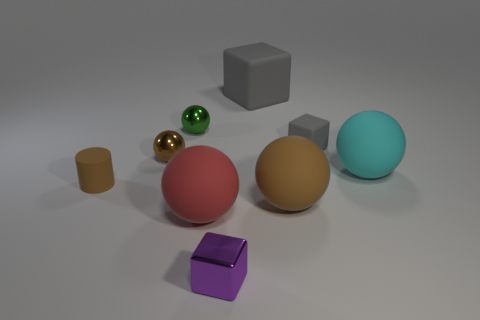Is there any other thing that has the same shape as the small brown rubber object?
Ensure brevity in your answer.  No. How big is the ball that is in front of the brown metal sphere and behind the brown cylinder?
Ensure brevity in your answer.  Large. There is a cube in front of the tiny matte object left of the big brown rubber thing; what color is it?
Keep it short and to the point. Purple. What number of purple things are either matte cylinders or matte blocks?
Ensure brevity in your answer.  0. There is a big thing that is both behind the tiny brown matte object and in front of the small gray cube; what is its color?
Give a very brief answer. Cyan. What number of big objects are brown balls or brown objects?
Provide a short and direct response. 1. The cyan thing that is the same shape as the red thing is what size?
Offer a terse response. Large. What shape is the large gray object?
Your answer should be very brief. Cube. Is the material of the tiny green ball the same as the brown ball that is on the left side of the green metallic object?
Ensure brevity in your answer.  Yes. What number of rubber things are either purple cubes or small brown spheres?
Your response must be concise. 0. 